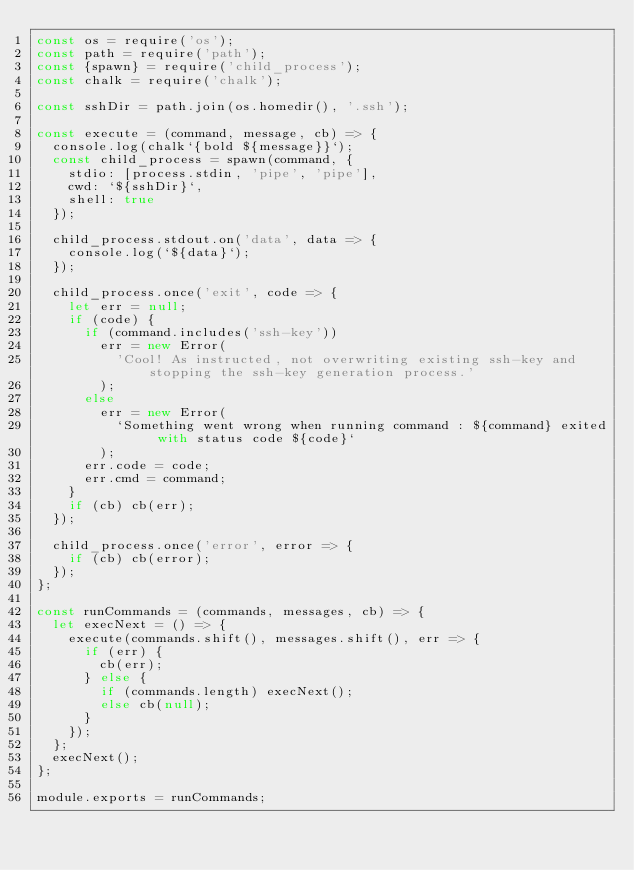<code> <loc_0><loc_0><loc_500><loc_500><_JavaScript_>const os = require('os');
const path = require('path');
const {spawn} = require('child_process');
const chalk = require('chalk');

const sshDir = path.join(os.homedir(), '.ssh');

const execute = (command, message, cb) => {
  console.log(chalk`{bold ${message}}`);
  const child_process = spawn(command, {
    stdio: [process.stdin, 'pipe', 'pipe'],
    cwd: `${sshDir}`,
    shell: true
  });

  child_process.stdout.on('data', data => {
    console.log(`${data}`);
  });

  child_process.once('exit', code => {
    let err = null;
    if (code) {
      if (command.includes('ssh-key'))
        err = new Error(
          'Cool! As instructed, not overwriting existing ssh-key and stopping the ssh-key generation process.'
        );
      else
        err = new Error(
          `Something went wrong when running command : ${command} exited with status code ${code}`
        );
      err.code = code;
      err.cmd = command;
    }
    if (cb) cb(err);
  });

  child_process.once('error', error => {
    if (cb) cb(error);
  });
};

const runCommands = (commands, messages, cb) => {
  let execNext = () => {
    execute(commands.shift(), messages.shift(), err => {
      if (err) {
        cb(err);
      } else {
        if (commands.length) execNext();
        else cb(null);
      }
    });
  };
  execNext();
};

module.exports = runCommands;
</code> 